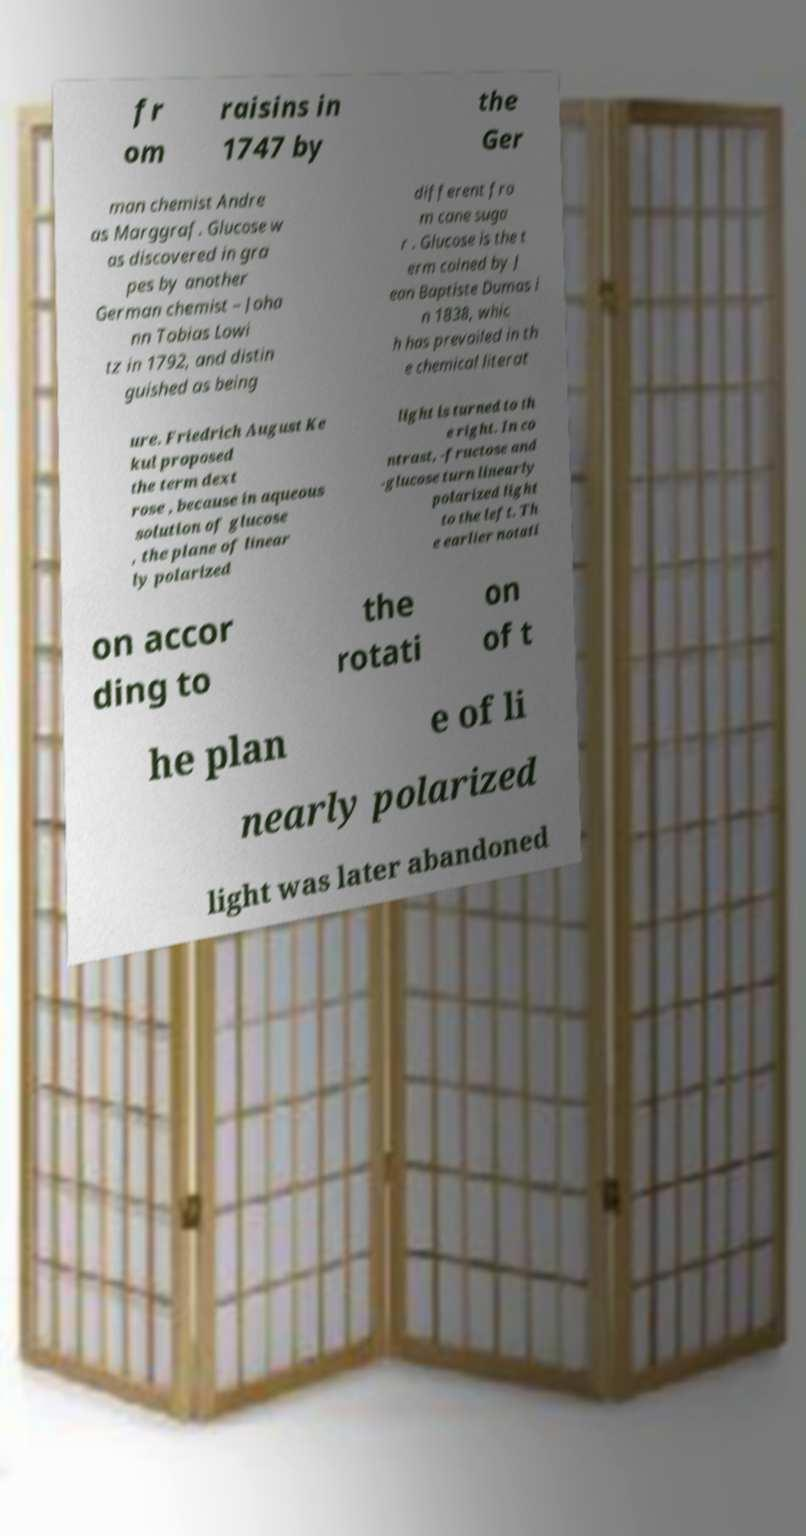Can you read and provide the text displayed in the image?This photo seems to have some interesting text. Can you extract and type it out for me? fr om raisins in 1747 by the Ger man chemist Andre as Marggraf. Glucose w as discovered in gra pes by another German chemist – Joha nn Tobias Lowi tz in 1792, and distin guished as being different fro m cane suga r . Glucose is the t erm coined by J ean Baptiste Dumas i n 1838, whic h has prevailed in th e chemical literat ure. Friedrich August Ke kul proposed the term dext rose , because in aqueous solution of glucose , the plane of linear ly polarized light is turned to th e right. In co ntrast, -fructose and -glucose turn linearly polarized light to the left. Th e earlier notati on accor ding to the rotati on of t he plan e of li nearly polarized light was later abandoned 